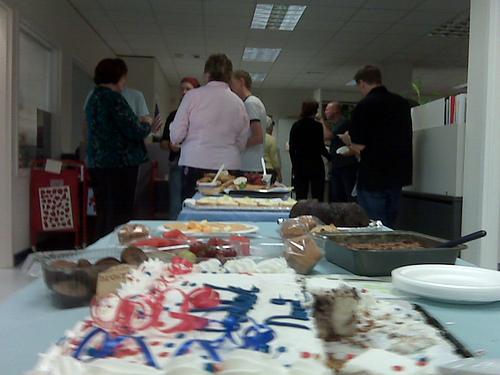What is there to eat besides cake?
Short answer required. Brownies. How many pieces of cake have been taken?
Answer briefly. 10. Are they having a birthday party?
Quick response, please. Yes. Are they in the army?
Be succinct. No. What kind of cake is that?
Keep it brief. Birthday. Is this taking place inside of a building?
Concise answer only. Yes. Is this cake for a wedding?
Concise answer only. No. Has the cake been cut?
Answer briefly. Yes. Did everyone contribute food?
Answer briefly. Yes. 